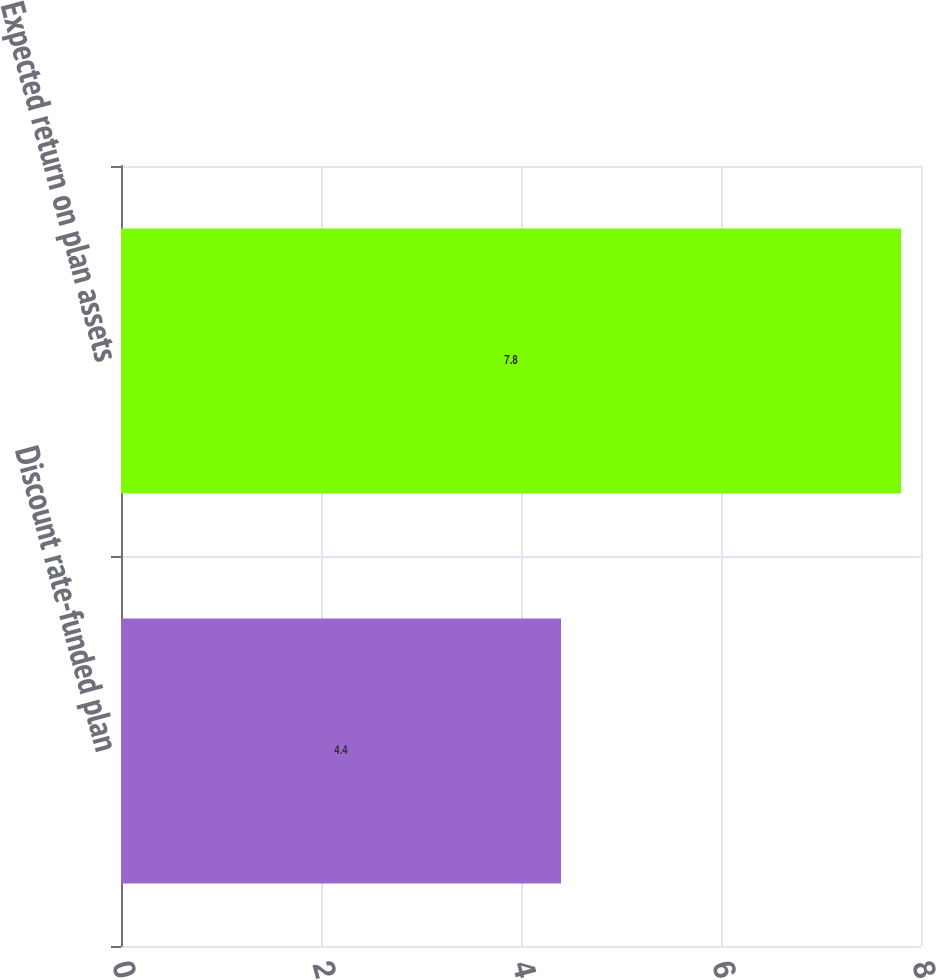Convert chart. <chart><loc_0><loc_0><loc_500><loc_500><bar_chart><fcel>Discount rate-funded plan<fcel>Expected return on plan assets<nl><fcel>4.4<fcel>7.8<nl></chart> 